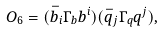Convert formula to latex. <formula><loc_0><loc_0><loc_500><loc_500>O _ { 6 } = ( \bar { b } _ { i } \Gamma _ { b } b ^ { i } ) ( \bar { q } _ { j } \Gamma _ { q } q ^ { j } ) ,</formula> 